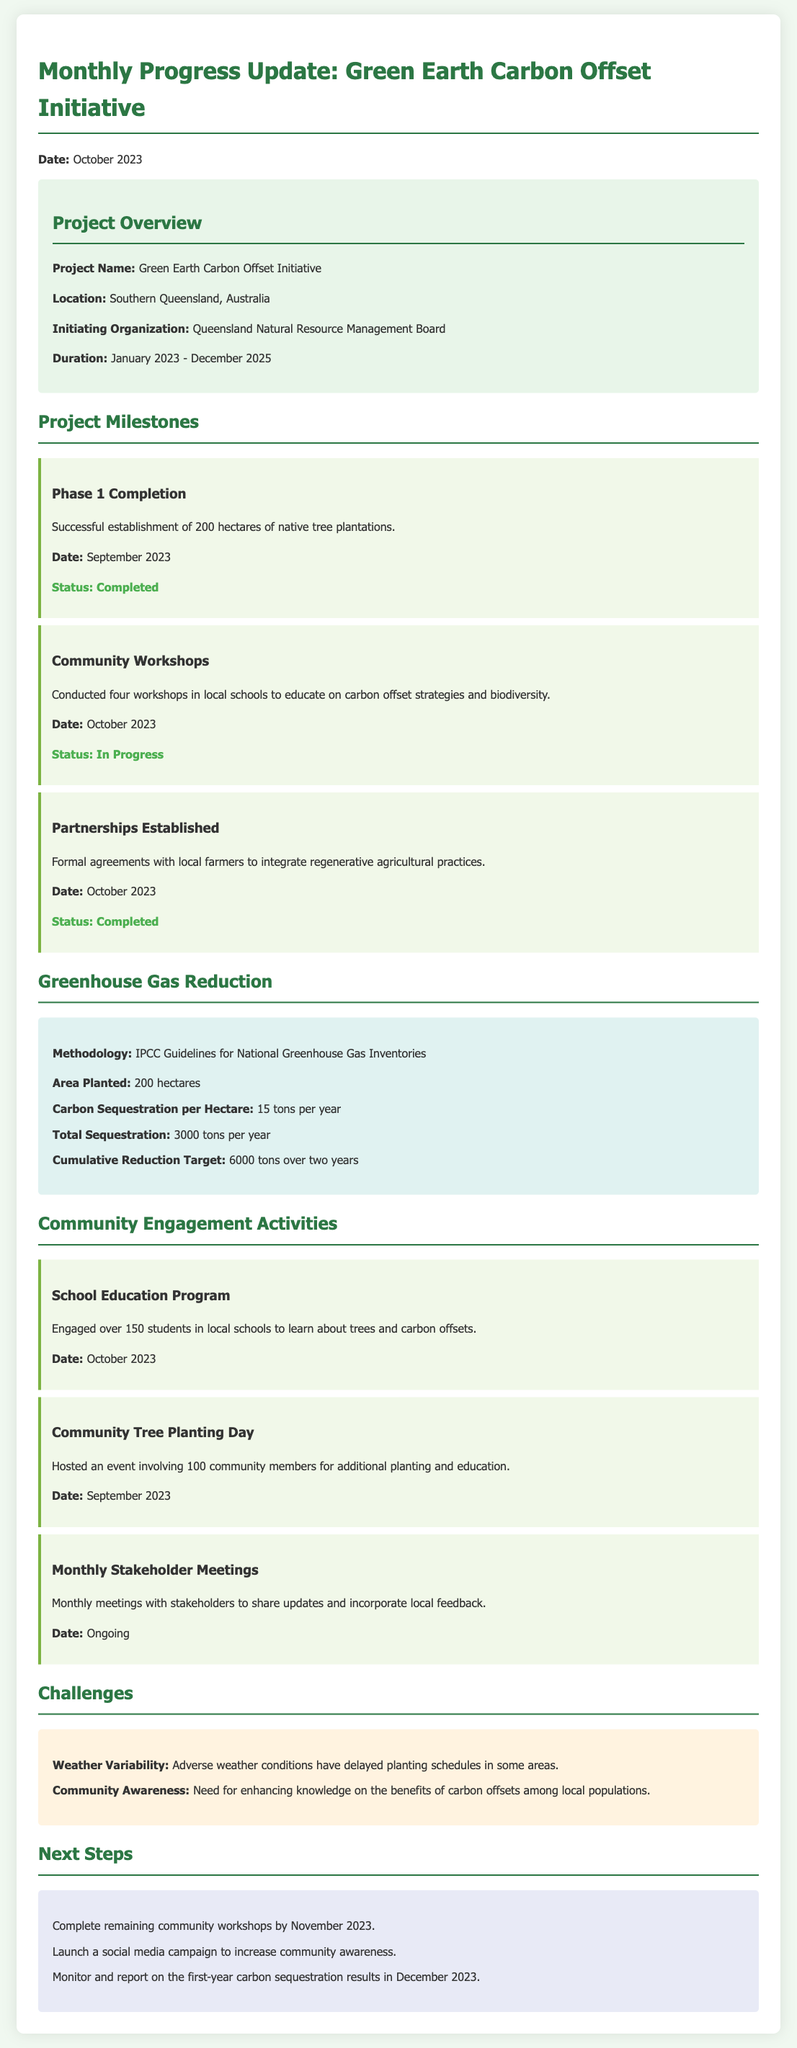What is the project name? The project name is clearly stated in the document's project overview section.
Answer: Green Earth Carbon Offset Initiative Where is the project located? The location of the project is provided in the project overview section.
Answer: Southern Queensland, Australia What was the status of Phase 1 Completion? The status of this milestone is clearly indicated within the milestone section.
Answer: Completed How many hectares of native tree plantations were established? The number of hectares is mentioned specifically under the milestone for Phase 1.
Answer: 200 hectares What is the total sequestration per year? The total sequestration is detailed in the greenhouse gas reduction section.
Answer: 3000 tons per year How many students were engaged in the school education program? This information is provided in the community engagement activities section.
Answer: Over 150 students What challenge is related to adverse weather conditions? The challenge refers to the specific issue listed in the challenges section.
Answer: Weather Variability What is one of the next steps planned for the initiative? The next steps are clearly outlined in the next steps section.
Answer: Complete remaining community workshops by November 2023 